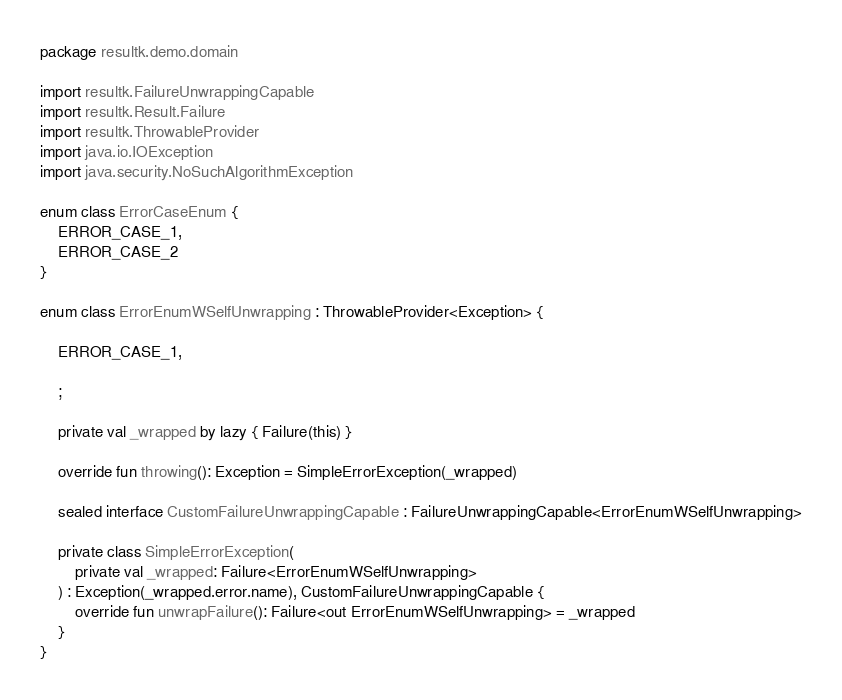Convert code to text. <code><loc_0><loc_0><loc_500><loc_500><_Kotlin_>package resultk.demo.domain

import resultk.FailureUnwrappingCapable
import resultk.Result.Failure
import resultk.ThrowableProvider
import java.io.IOException
import java.security.NoSuchAlgorithmException

enum class ErrorCaseEnum {
    ERROR_CASE_1,
    ERROR_CASE_2
}

enum class ErrorEnumWSelfUnwrapping : ThrowableProvider<Exception> {

    ERROR_CASE_1,

    ;

    private val _wrapped by lazy { Failure(this) }

    override fun throwing(): Exception = SimpleErrorException(_wrapped)

    sealed interface CustomFailureUnwrappingCapable : FailureUnwrappingCapable<ErrorEnumWSelfUnwrapping>

    private class SimpleErrorException(
        private val _wrapped: Failure<ErrorEnumWSelfUnwrapping>
    ) : Exception(_wrapped.error.name), CustomFailureUnwrappingCapable {
        override fun unwrapFailure(): Failure<out ErrorEnumWSelfUnwrapping> = _wrapped
    }
}

</code> 